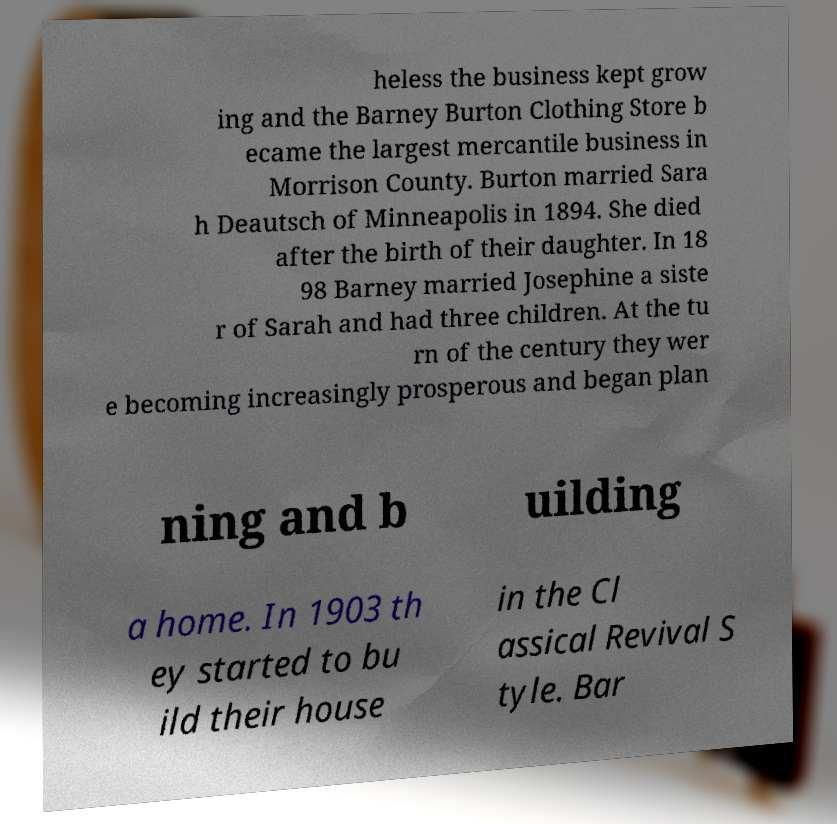There's text embedded in this image that I need extracted. Can you transcribe it verbatim? heless the business kept grow ing and the Barney Burton Clothing Store b ecame the largest mercantile business in Morrison County. Burton married Sara h Deautsch of Minneapolis in 1894. She died after the birth of their daughter. In 18 98 Barney married Josephine a siste r of Sarah and had three children. At the tu rn of the century they wer e becoming increasingly prosperous and began plan ning and b uilding a home. In 1903 th ey started to bu ild their house in the Cl assical Revival S tyle. Bar 